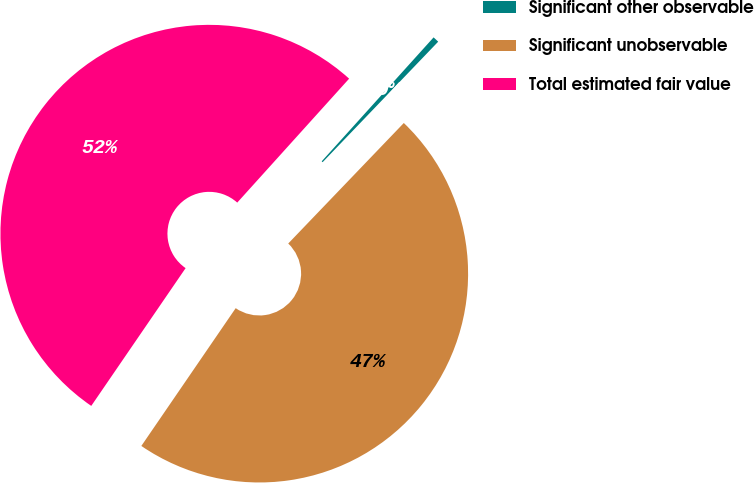Convert chart to OTSL. <chart><loc_0><loc_0><loc_500><loc_500><pie_chart><fcel>Significant other observable<fcel>Significant unobservable<fcel>Total estimated fair value<nl><fcel>0.48%<fcel>47.39%<fcel>52.13%<nl></chart> 